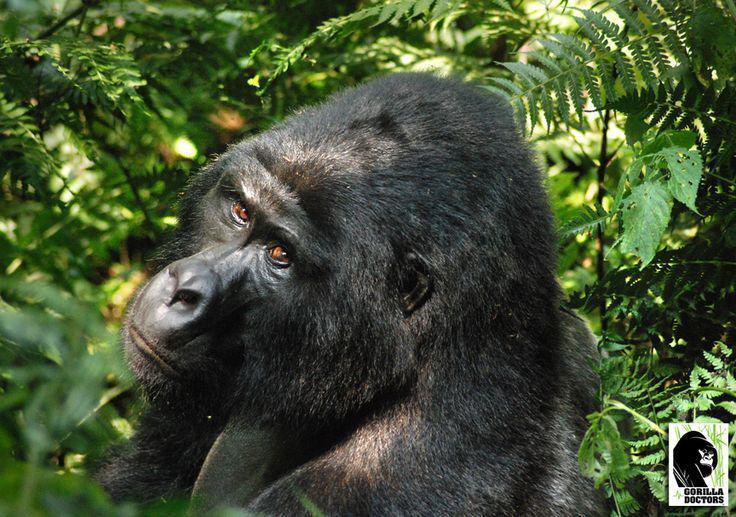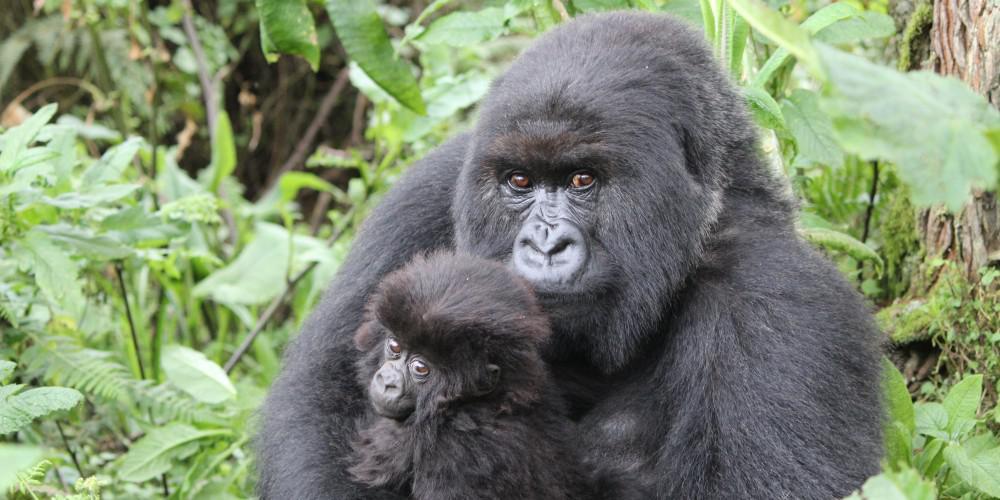The first image is the image on the left, the second image is the image on the right. For the images shown, is this caption "Atleast 3 animals in every picture." true? Answer yes or no. No. 